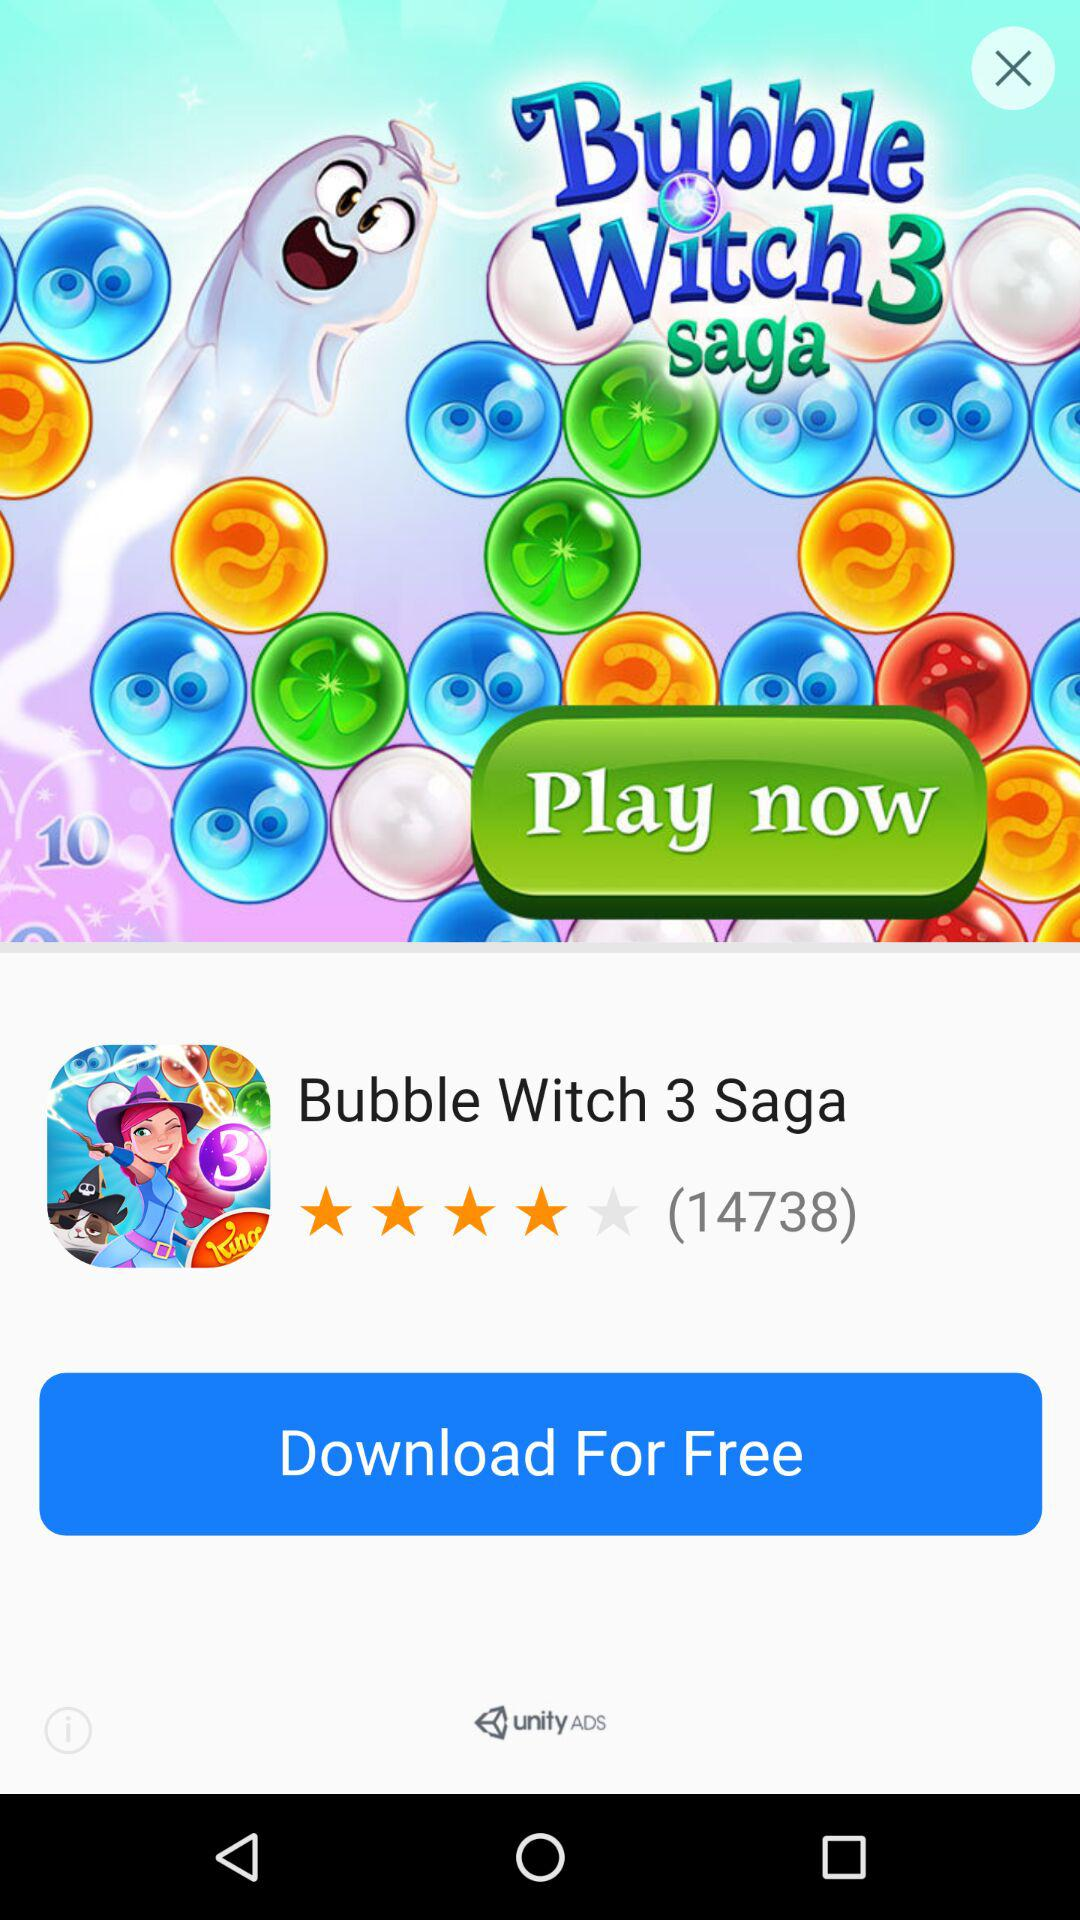What is the rating of the game? The rating of the game is 4 stars. 